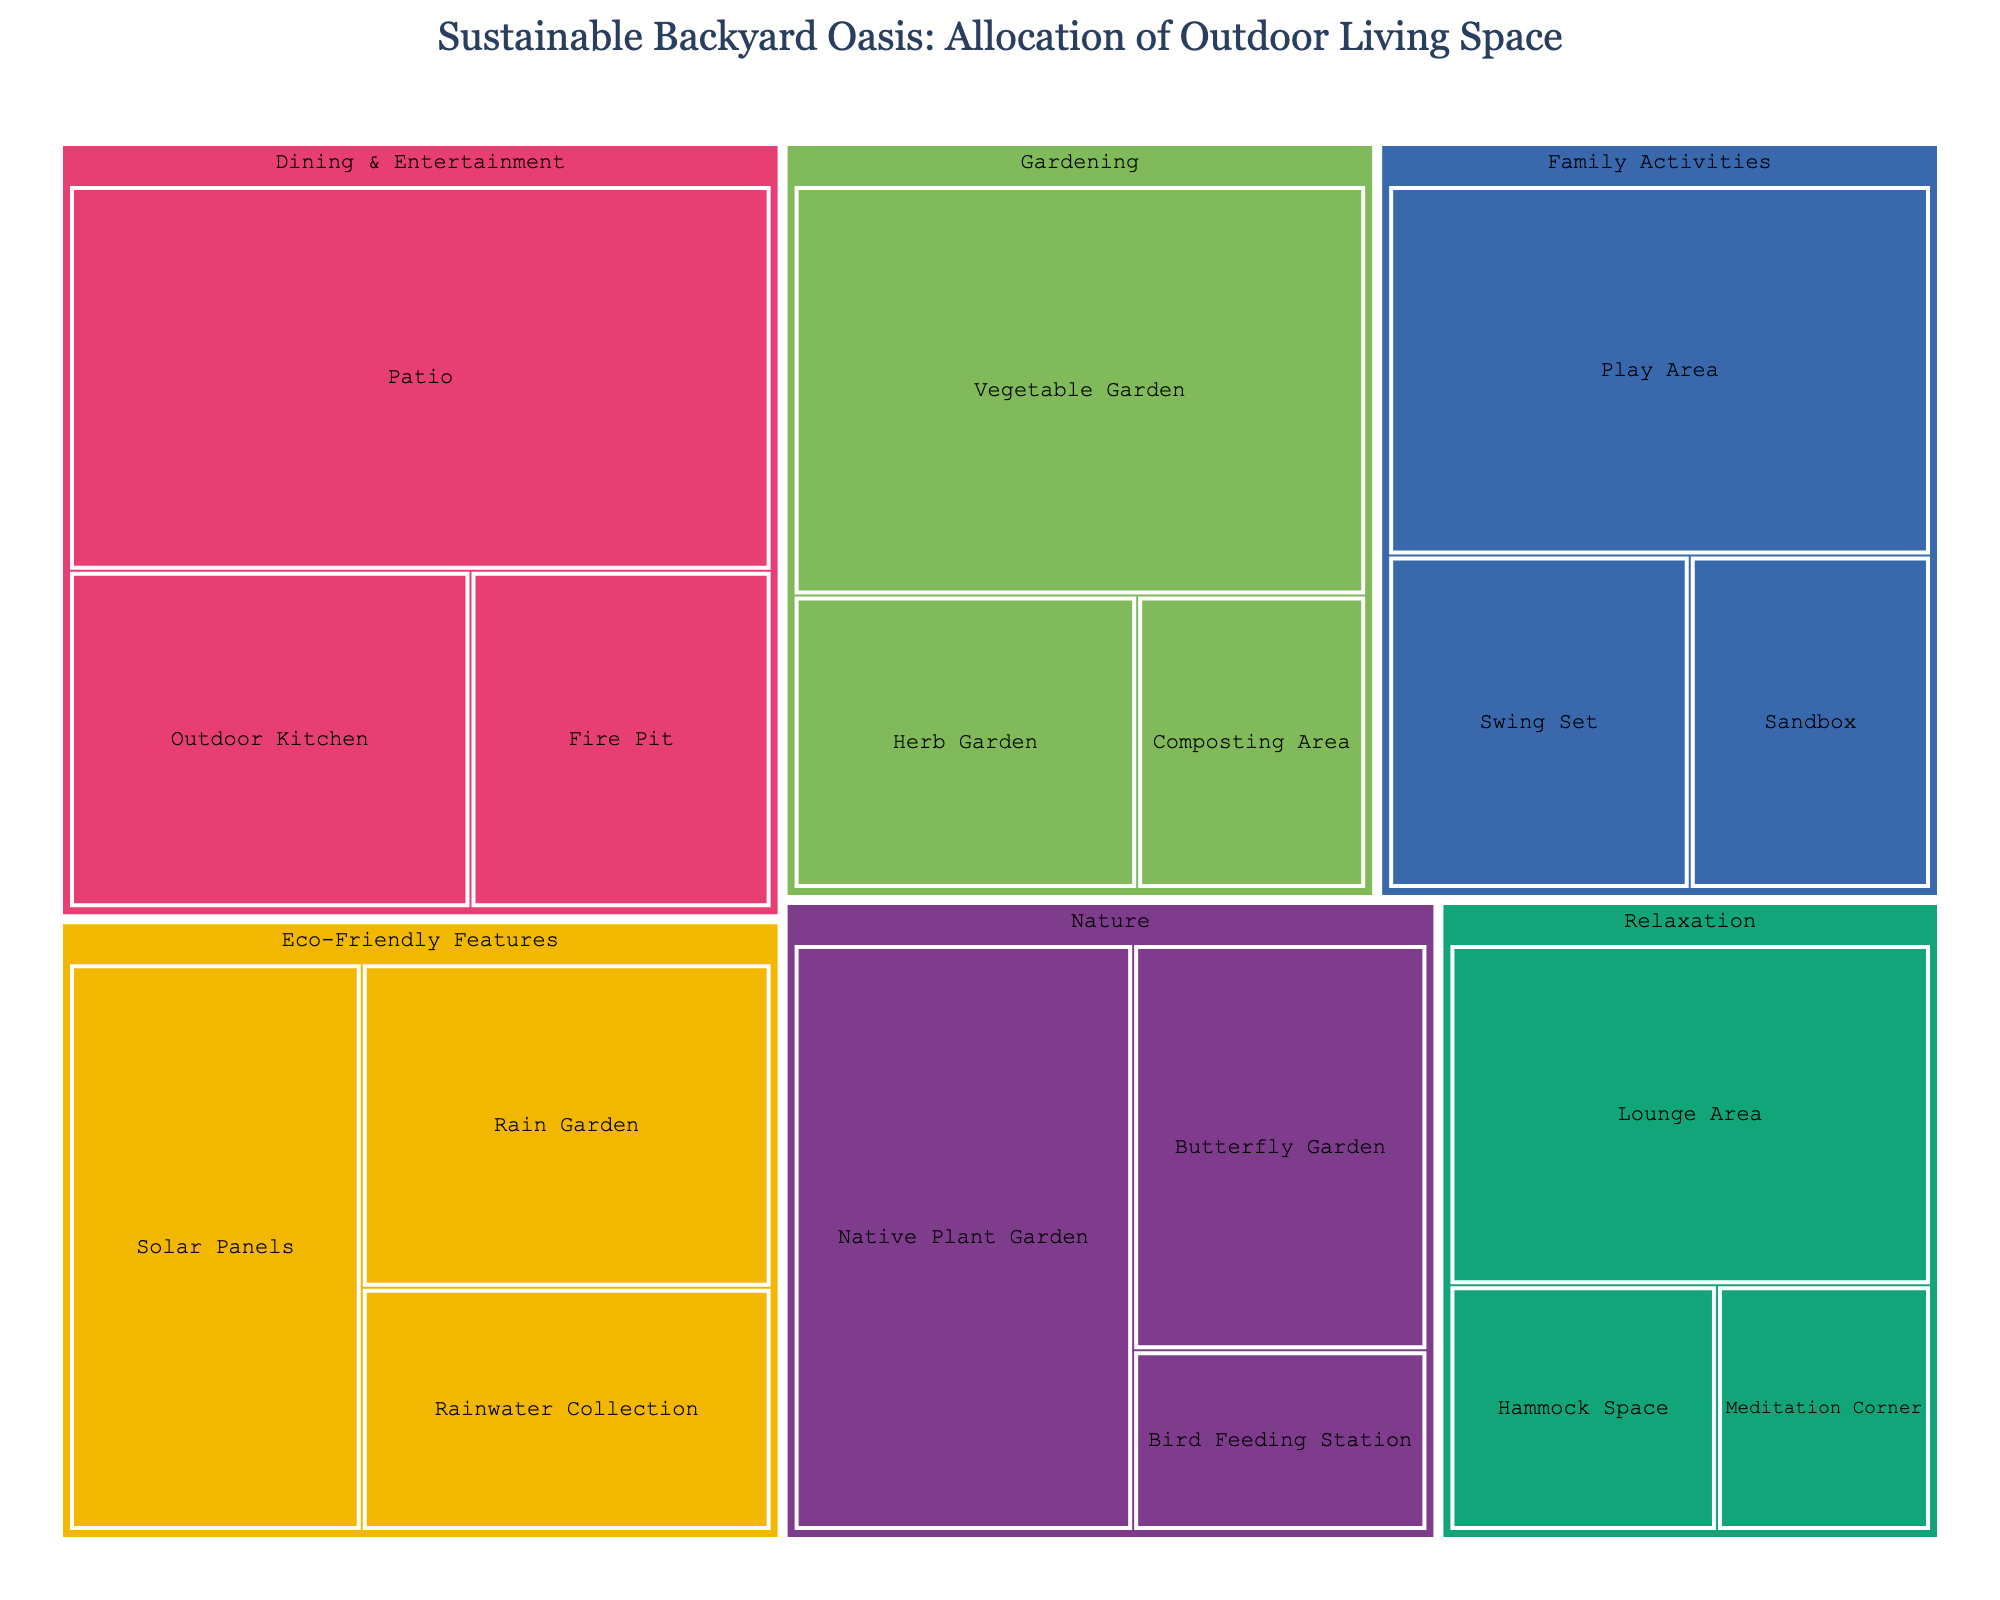What's the largest category in terms of size allocation? To identify the largest category in terms of size allocation, we look at the overall space each category occupies. The largest category is 'Dining & Entertainment' with a Patio (40 sq ft), Outdoor Kitchen (20 sq ft), and Fire Pit (15 sq ft) totaling 75 sq ft.
Answer: Dining & Entertainment What's the total size allocated to Relaxation areas? To find the total space allocated to Relaxation, sum up all subcategories: Lounge Area (25 sq ft) + Hammock Space (10 sq ft) + Meditation Corner (8 sq ft) = 43 sq ft.
Answer: 43 sq ft Which subcategory has the smallest size in the Family Activities category? Within the Family Activities category, we compare the sizes: Play Area (30 sq ft), Sandbox (12 sq ft), and Swing Set (15 sq ft). The smallest is the Sandbox at 12 sq ft.
Answer: Sandbox Is the Vegetable Garden larger or smaller than the Patio? Both sizes can be directly compared: Vegetable Garden (35 sq ft) and Patio (40 sq ft). The Vegetable Garden is smaller than the Patio.
Answer: Smaller What is the combined size of all Eco-Friendly Features? Sum up the areas allocated to Eco-Friendly Features: Rain Garden (20 sq ft), Solar Panels (25 sq ft), and Rainwater Collection (15 sq ft) totaling 60 sq ft.
Answer: 60 sq ft How does the size of the Bird Feeding Station compare to the Hammock Space? Bird Feeding Station (8 sq ft) is compared to Hammock Space (10 sq ft); the Bird Feeding Station is smaller.
Answer: Smaller Which subcategory has the largest size in the 'Nature' category? Compare the sizes in the Nature category: Native Plant Garden (30 sq ft), Butterfly Garden (18 sq ft), and Bird Feeding Station (8 sq ft). The largest is the Native Plant Garden with 30 sq ft.
Answer: Native Plant Garden What's the difference in size between the Solar Panels and the Fire Pit? Subtract the size of the Fire Pit from the size of the Solar Panels: 25 sq ft - 15 sq ft = 10 sq ft.
Answer: 10 sq ft What functional area has the second largest total size allocation? First, calculate the total size for each functional area, then find the second largest: 
1. Dining & Entertainment: 75 sq ft
2. Gardening: 60 sq ft
3. Eco-Friendly Features: 60 sq ft
4. Relaxation: 43 sq ft
5. Nature: 56 sq ft
6. Family Activities: 57 sq ft
The second largest is a tie between Eco-Friendly Features and Gardening, both with 60 sq ft.
Answer: Gardening and Eco-Friendly Features Which category has the most subcategories, and how many are there? Count the number of subcategories for each category: 
- Relaxation: 3
- Family Activities: 3
- Dining & Entertainment: 3
- Gardening: 3
- Eco-Friendly Features: 3
- Nature: 3
All categories have the same number of subcategories.
Answer: All have 3 